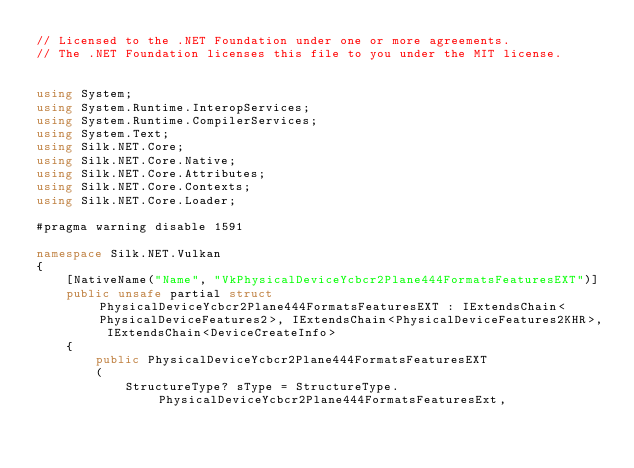<code> <loc_0><loc_0><loc_500><loc_500><_C#_>// Licensed to the .NET Foundation under one or more agreements.
// The .NET Foundation licenses this file to you under the MIT license.


using System;
using System.Runtime.InteropServices;
using System.Runtime.CompilerServices;
using System.Text;
using Silk.NET.Core;
using Silk.NET.Core.Native;
using Silk.NET.Core.Attributes;
using Silk.NET.Core.Contexts;
using Silk.NET.Core.Loader;

#pragma warning disable 1591

namespace Silk.NET.Vulkan
{
    [NativeName("Name", "VkPhysicalDeviceYcbcr2Plane444FormatsFeaturesEXT")]
    public unsafe partial struct PhysicalDeviceYcbcr2Plane444FormatsFeaturesEXT : IExtendsChain<PhysicalDeviceFeatures2>, IExtendsChain<PhysicalDeviceFeatures2KHR>, IExtendsChain<DeviceCreateInfo>
    {
        public PhysicalDeviceYcbcr2Plane444FormatsFeaturesEXT
        (
            StructureType? sType = StructureType.PhysicalDeviceYcbcr2Plane444FormatsFeaturesExt,</code> 